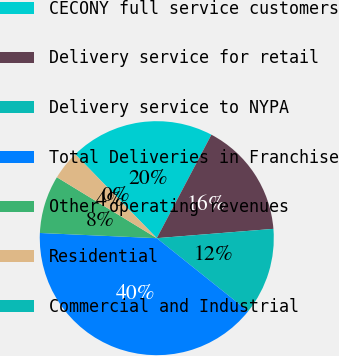<chart> <loc_0><loc_0><loc_500><loc_500><pie_chart><fcel>CECONY full service customers<fcel>Delivery service for retail<fcel>Delivery service to NYPA<fcel>Total Deliveries in Franchise<fcel>Other operating revenues<fcel>Residential<fcel>Commercial and Industrial<nl><fcel>19.99%<fcel>16.0%<fcel>12.0%<fcel>39.97%<fcel>8.01%<fcel>4.01%<fcel>0.01%<nl></chart> 